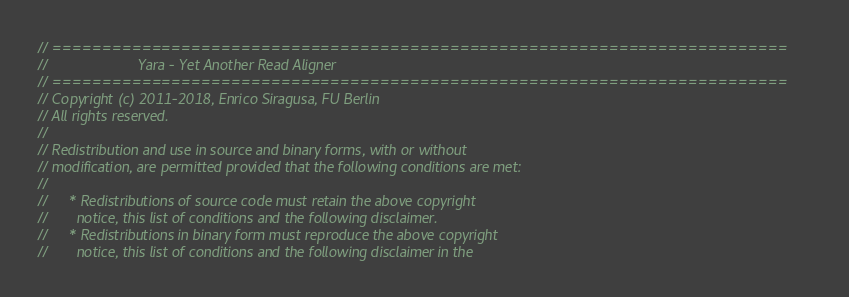<code> <loc_0><loc_0><loc_500><loc_500><_C_>// ==========================================================================
//                      Yara - Yet Another Read Aligner
// ==========================================================================
// Copyright (c) 2011-2018, Enrico Siragusa, FU Berlin
// All rights reserved.
//
// Redistribution and use in source and binary forms, with or without
// modification, are permitted provided that the following conditions are met:
//
//     * Redistributions of source code must retain the above copyright
//       notice, this list of conditions and the following disclaimer.
//     * Redistributions in binary form must reproduce the above copyright
//       notice, this list of conditions and the following disclaimer in the</code> 